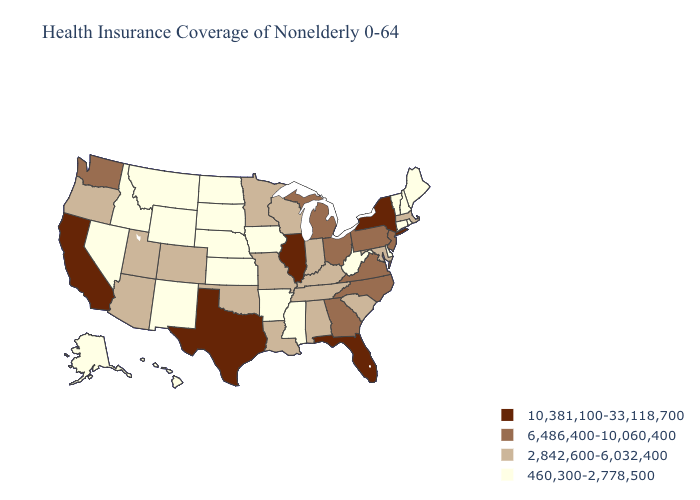Does South Carolina have the highest value in the USA?
Give a very brief answer. No. Name the states that have a value in the range 6,486,400-10,060,400?
Write a very short answer. Georgia, Michigan, New Jersey, North Carolina, Ohio, Pennsylvania, Virginia, Washington. Name the states that have a value in the range 6,486,400-10,060,400?
Short answer required. Georgia, Michigan, New Jersey, North Carolina, Ohio, Pennsylvania, Virginia, Washington. How many symbols are there in the legend?
Answer briefly. 4. What is the lowest value in states that border Nebraska?
Be succinct. 460,300-2,778,500. What is the highest value in the MidWest ?
Be succinct. 10,381,100-33,118,700. Name the states that have a value in the range 460,300-2,778,500?
Give a very brief answer. Alaska, Arkansas, Connecticut, Delaware, Hawaii, Idaho, Iowa, Kansas, Maine, Mississippi, Montana, Nebraska, Nevada, New Hampshire, New Mexico, North Dakota, Rhode Island, South Dakota, Vermont, West Virginia, Wyoming. What is the value of New Jersey?
Write a very short answer. 6,486,400-10,060,400. Does Oklahoma have the highest value in the South?
Concise answer only. No. Does Colorado have the lowest value in the USA?
Answer briefly. No. Among the states that border Maryland , which have the highest value?
Short answer required. Pennsylvania, Virginia. Name the states that have a value in the range 6,486,400-10,060,400?
Short answer required. Georgia, Michigan, New Jersey, North Carolina, Ohio, Pennsylvania, Virginia, Washington. Name the states that have a value in the range 2,842,600-6,032,400?
Quick response, please. Alabama, Arizona, Colorado, Indiana, Kentucky, Louisiana, Maryland, Massachusetts, Minnesota, Missouri, Oklahoma, Oregon, South Carolina, Tennessee, Utah, Wisconsin. What is the value of Illinois?
Give a very brief answer. 10,381,100-33,118,700. Which states have the lowest value in the USA?
Short answer required. Alaska, Arkansas, Connecticut, Delaware, Hawaii, Idaho, Iowa, Kansas, Maine, Mississippi, Montana, Nebraska, Nevada, New Hampshire, New Mexico, North Dakota, Rhode Island, South Dakota, Vermont, West Virginia, Wyoming. 